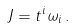Convert formula to latex. <formula><loc_0><loc_0><loc_500><loc_500>J = t ^ { i } \omega _ { i } \, .</formula> 